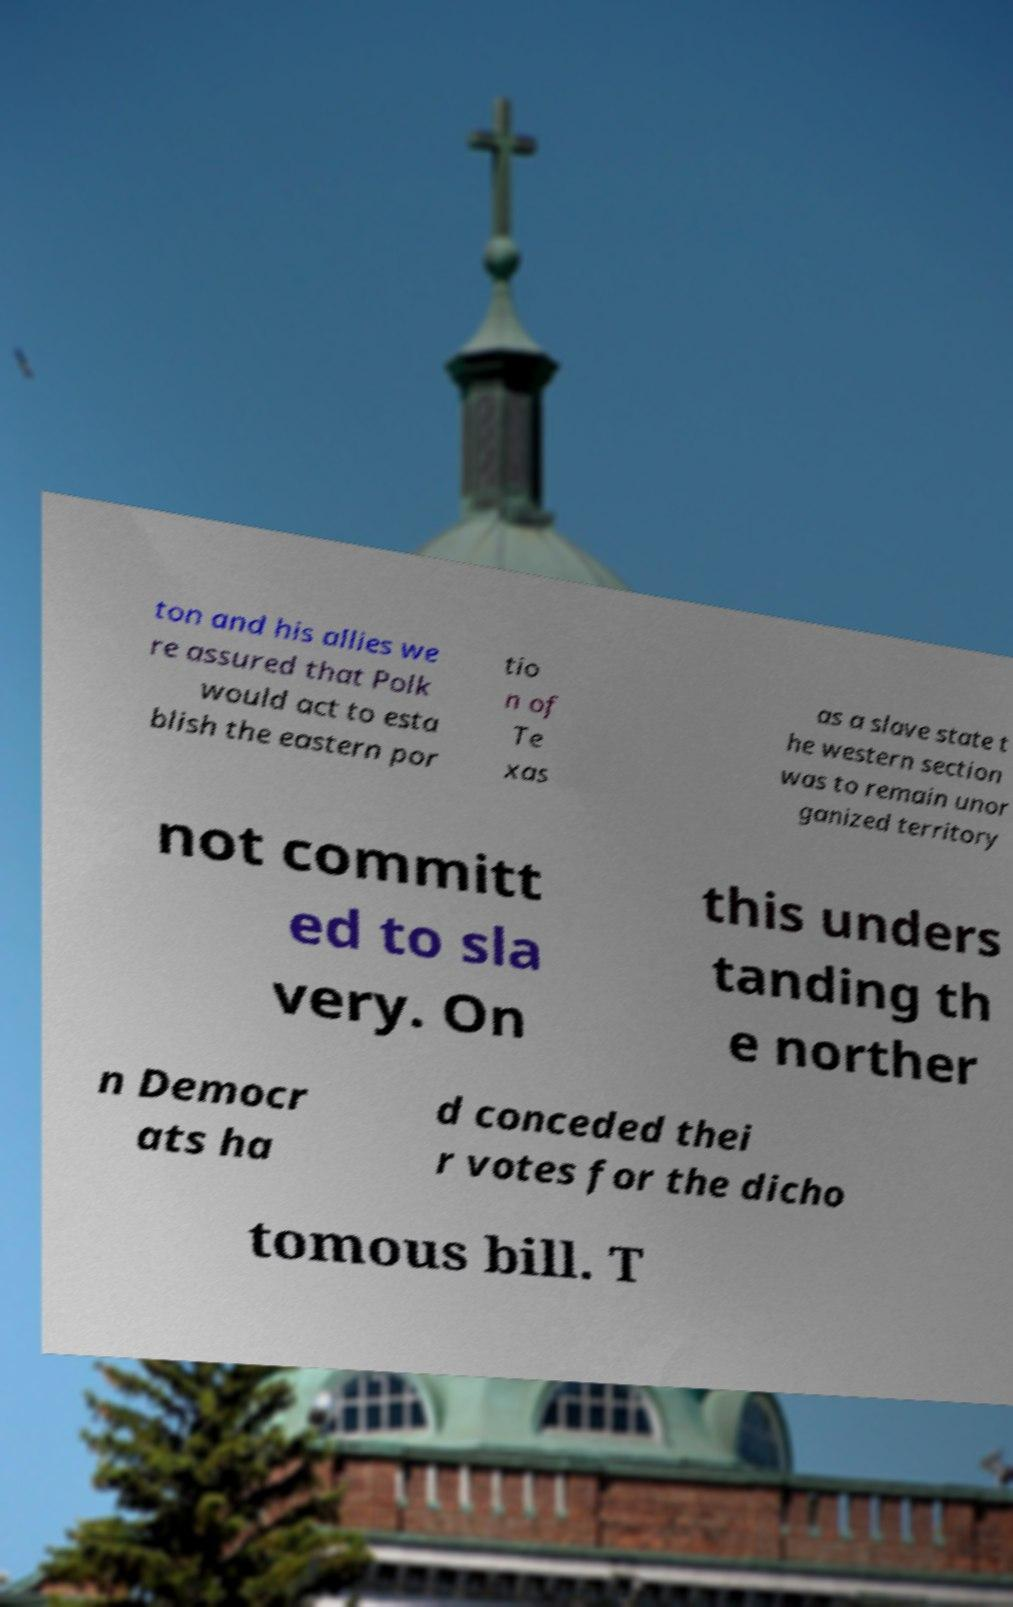Please read and relay the text visible in this image. What does it say? ton and his allies we re assured that Polk would act to esta blish the eastern por tio n of Te xas as a slave state t he western section was to remain unor ganized territory not committ ed to sla very. On this unders tanding th e norther n Democr ats ha d conceded thei r votes for the dicho tomous bill. T 